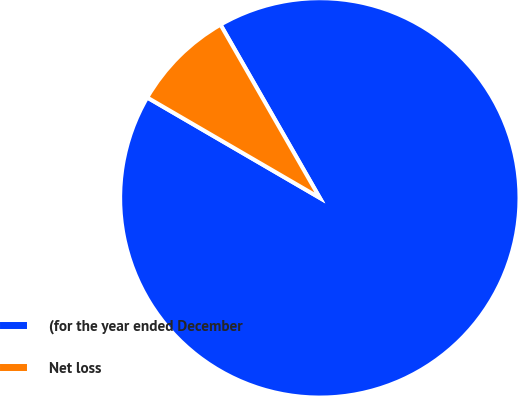Convert chart. <chart><loc_0><loc_0><loc_500><loc_500><pie_chart><fcel>(for the year ended December<fcel>Net loss<nl><fcel>91.67%<fcel>8.33%<nl></chart> 